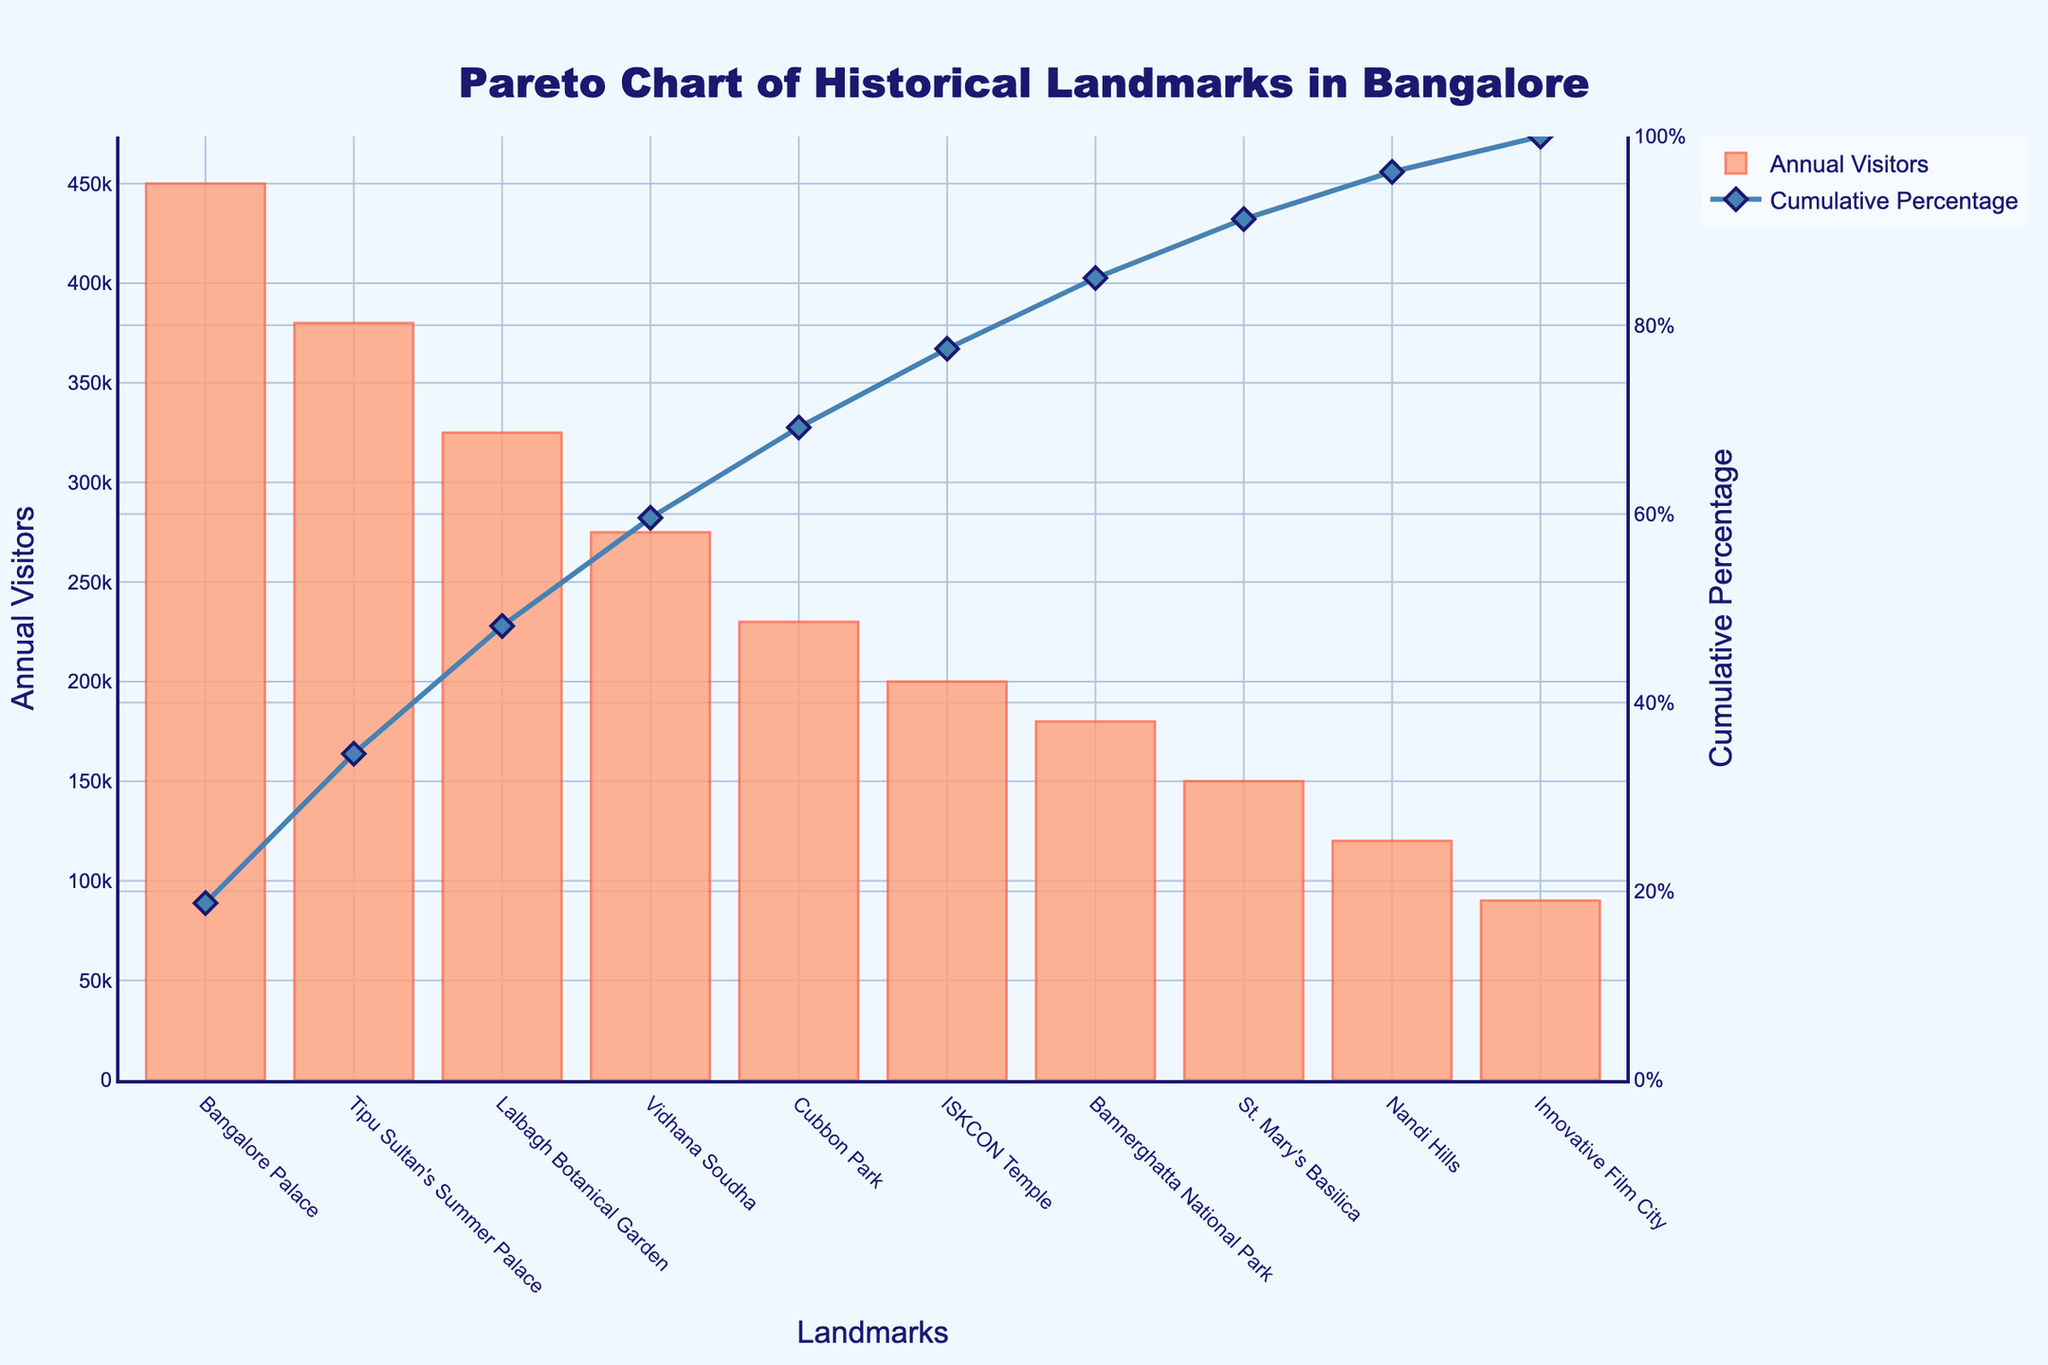What is the landmark with the highest number of annual visitors? The Pareto chart shows the annual visitors for each landmark. The landmark with the highest bar represents the most visitors.
Answer: Bangalore Palace Which landmark has the lowest number of annual visitors? The landmark with the shortest bar in the Pareto chart represents the fewest visitors.
Answer: Innovative Film City What is the cumulative percentage after the third most visited landmark? The lines on the chart represent cumulative percentages. The third landmark “Lalbagh Botanical Garden” has an associated point on the cumulative percentage line. This value needs to be read directly from the chart.
Answer: Approximately 72.8% How many landmarks have annual visitors between 150,000 and 250,000? Identify the bars within the range of 150,000 and 250,000 annual visitors by counting the relevant bars on the chart within this range.
Answer: 3 (Cubbon Park, ISKCON Temple, St. Mary's Basilica) What is the total number of annual visitors for the top three most visited landmarks? Sum the annual visitors of the top three landmarks by adding their values directly from the chart.
Answer: 1,155,000 How much more visitors does Bangalore Palace have compared to the ISKCON Temple? Find the annual visitors for both Bangalore Palace and ISKCON Temple and then subtract the visitors of ISKCON Temple from Bangalore Palace to get the difference.
Answer: 250,000 What cumulative percentage does Vidhana Soudha reach? Find the point on the cumulative percentage line that corresponds to Vidhana Soudha on the chart and read the value.
Answer: Approximately 77.1% Which landmark crosses the 50% cumulative percentage threshold? Identify the point on the cumulative percentage line where it crosses the 50% mark and find the corresponding landmark.
Answer: Tipu Sultan's Summer Palace How does the number of visitors to Cubbon Park compare to Bannerghatta National Park? Compare the heights of the bars representing Cubbon Park and Bannerghatta National Park to determine which one is higher.
Answer: Cubbon Park has more visitors What is the average number of annual visitors for all the landmarks? Sum all the annual visitors for each landmark and then divide by the total number of landmarks to find the average.
Answer: 240,000 